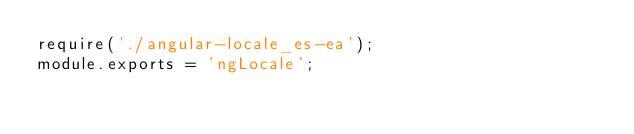<code> <loc_0><loc_0><loc_500><loc_500><_JavaScript_>require('./angular-locale_es-ea');
module.exports = 'ngLocale';
</code> 